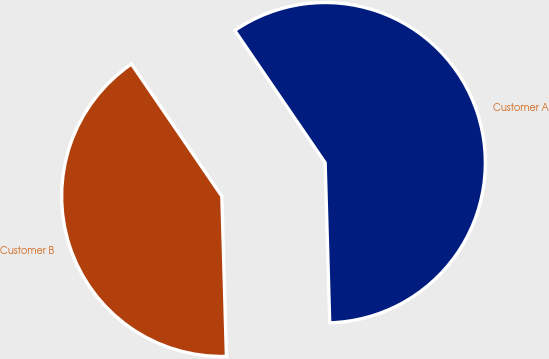Convert chart to OTSL. <chart><loc_0><loc_0><loc_500><loc_500><pie_chart><fcel>Customer A<fcel>Customer B<nl><fcel>59.09%<fcel>40.91%<nl></chart> 